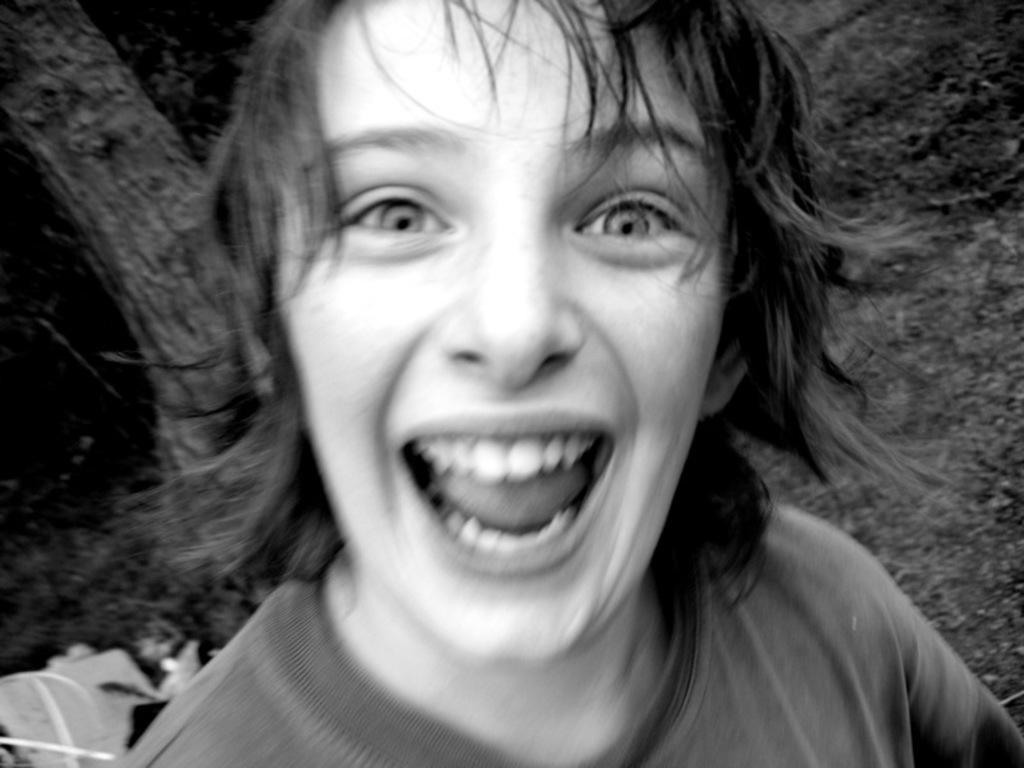Could you give a brief overview of what you see in this image? This is a black and white picture. Here we can see a person who is smiling. There is a dark background. On the left side of the image we can see objects. 